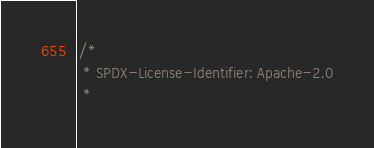<code> <loc_0><loc_0><loc_500><loc_500><_Scala_>/*
 * SPDX-License-Identifier: Apache-2.0
 *</code> 